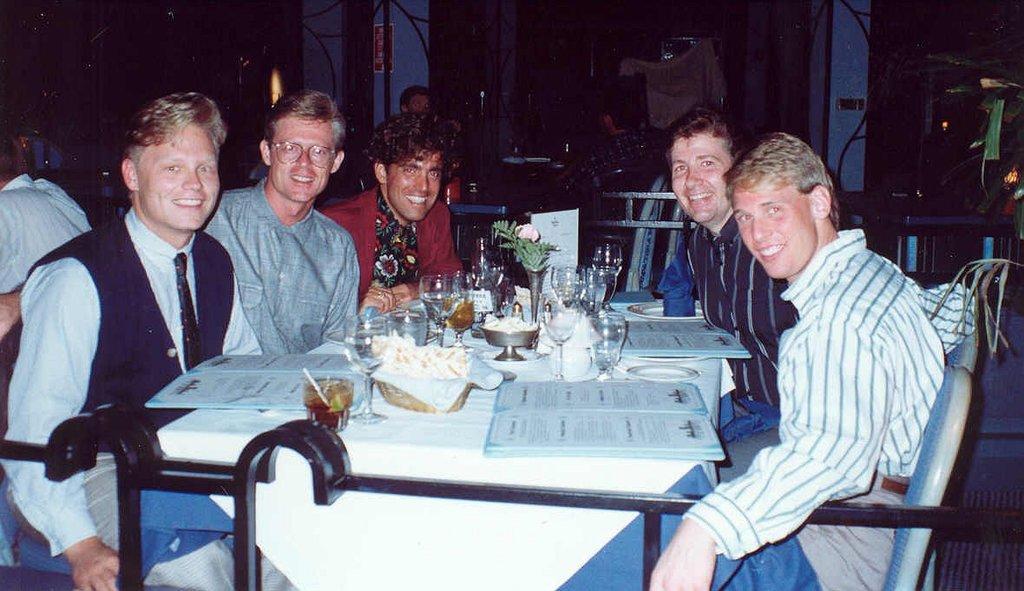In one or two sentences, can you explain what this image depicts? In this image we can see few people and chairs. In the middle of the image there are groups of objects placed on a table. Behind the persons we can see two pillars. 